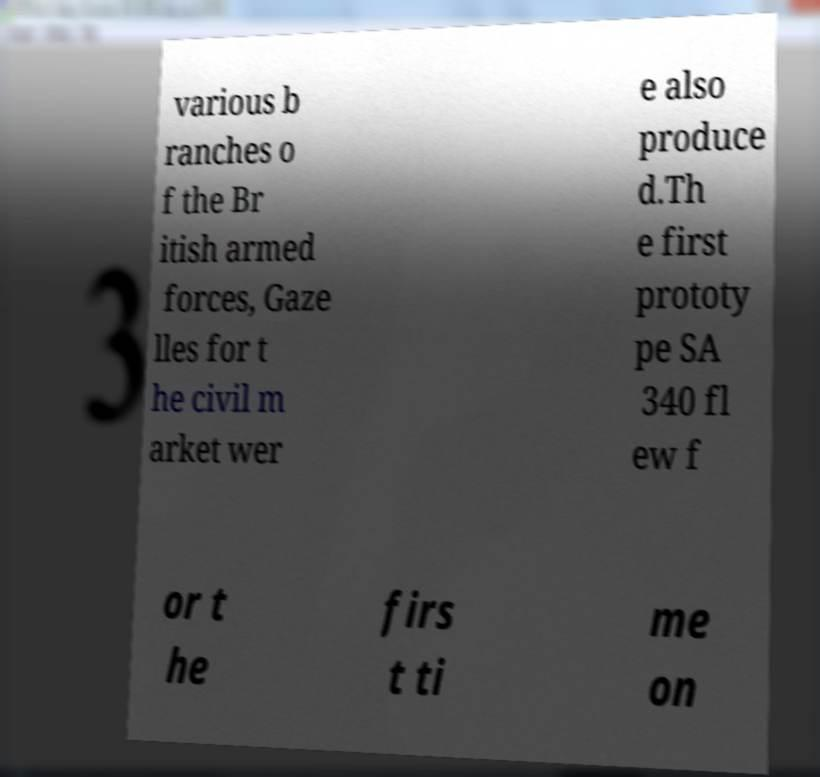Please identify and transcribe the text found in this image. various b ranches o f the Br itish armed forces, Gaze lles for t he civil m arket wer e also produce d.Th e first prototy pe SA 340 fl ew f or t he firs t ti me on 